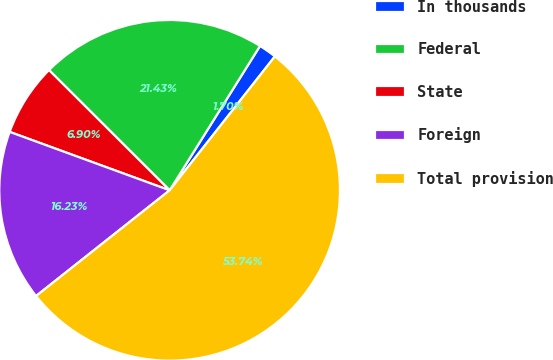<chart> <loc_0><loc_0><loc_500><loc_500><pie_chart><fcel>In thousands<fcel>Federal<fcel>State<fcel>Foreign<fcel>Total provision<nl><fcel>1.7%<fcel>21.43%<fcel>6.9%<fcel>16.23%<fcel>53.75%<nl></chart> 